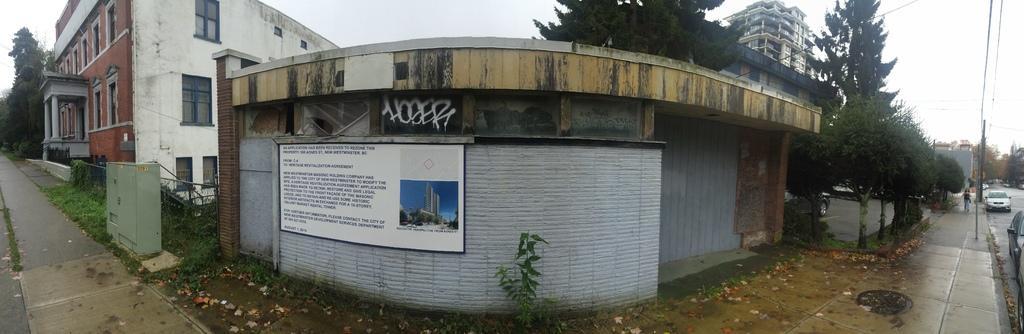In one or two sentences, can you explain what this image depicts? There are buildings. There is a board at the center. There are trees and walkways on the either sides. A person is walking a the right. There are electric poles and wires at the right. There are vehicles on the road at the right corner. There are trees at the back. 